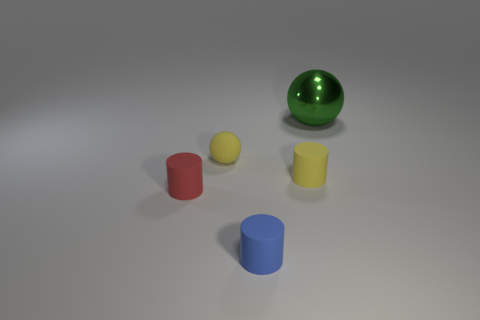Is there a cyan object?
Provide a succinct answer. No. There is a tiny rubber cylinder behind the tiny cylinder that is on the left side of the small yellow ball; is there a matte object in front of it?
Your answer should be very brief. Yes. Are there any other things that are the same size as the metal ball?
Your answer should be compact. No. Do the blue rubber thing and the small red object left of the small yellow cylinder have the same shape?
Your response must be concise. Yes. There is a object that is right of the small yellow rubber object that is in front of the sphere in front of the green shiny ball; what color is it?
Keep it short and to the point. Green. How many things are rubber objects that are in front of the tiny matte ball or large metallic objects that are to the right of the matte sphere?
Ensure brevity in your answer.  4. How many other objects are there of the same color as the big ball?
Provide a succinct answer. 0. Does the tiny rubber thing that is on the left side of the small yellow ball have the same shape as the tiny blue object?
Your answer should be compact. Yes. Is the number of small balls that are right of the yellow matte cylinder less than the number of tiny yellow cylinders?
Provide a succinct answer. Yes. Are there any yellow things made of the same material as the big green sphere?
Your answer should be compact. No. 